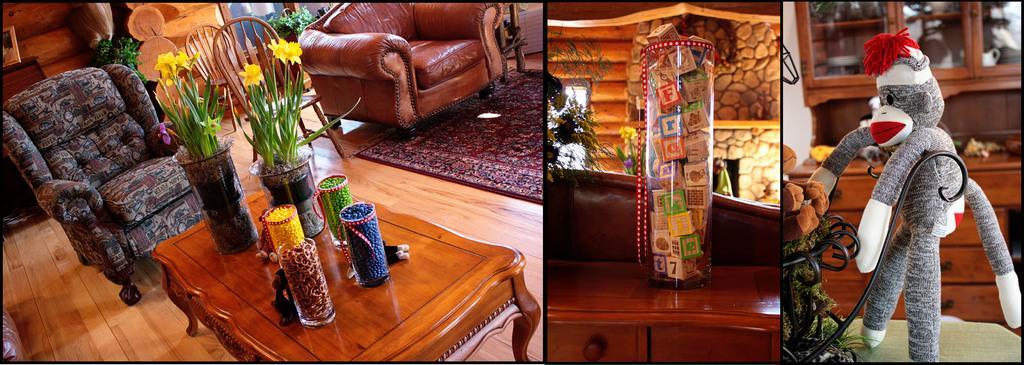How would you summarize this image in a sentence or two? The image is collage of three different pictures. In the first picture there are two sofas, two chairs, one table, two plants and three different jars, the table is placed in the center. In the second picture there is a table, on the table there is a plant and a toy, in the background there is stoned picture. In the third picture there is a monkey toy placed to a stand. In the background there is a cupboard. 